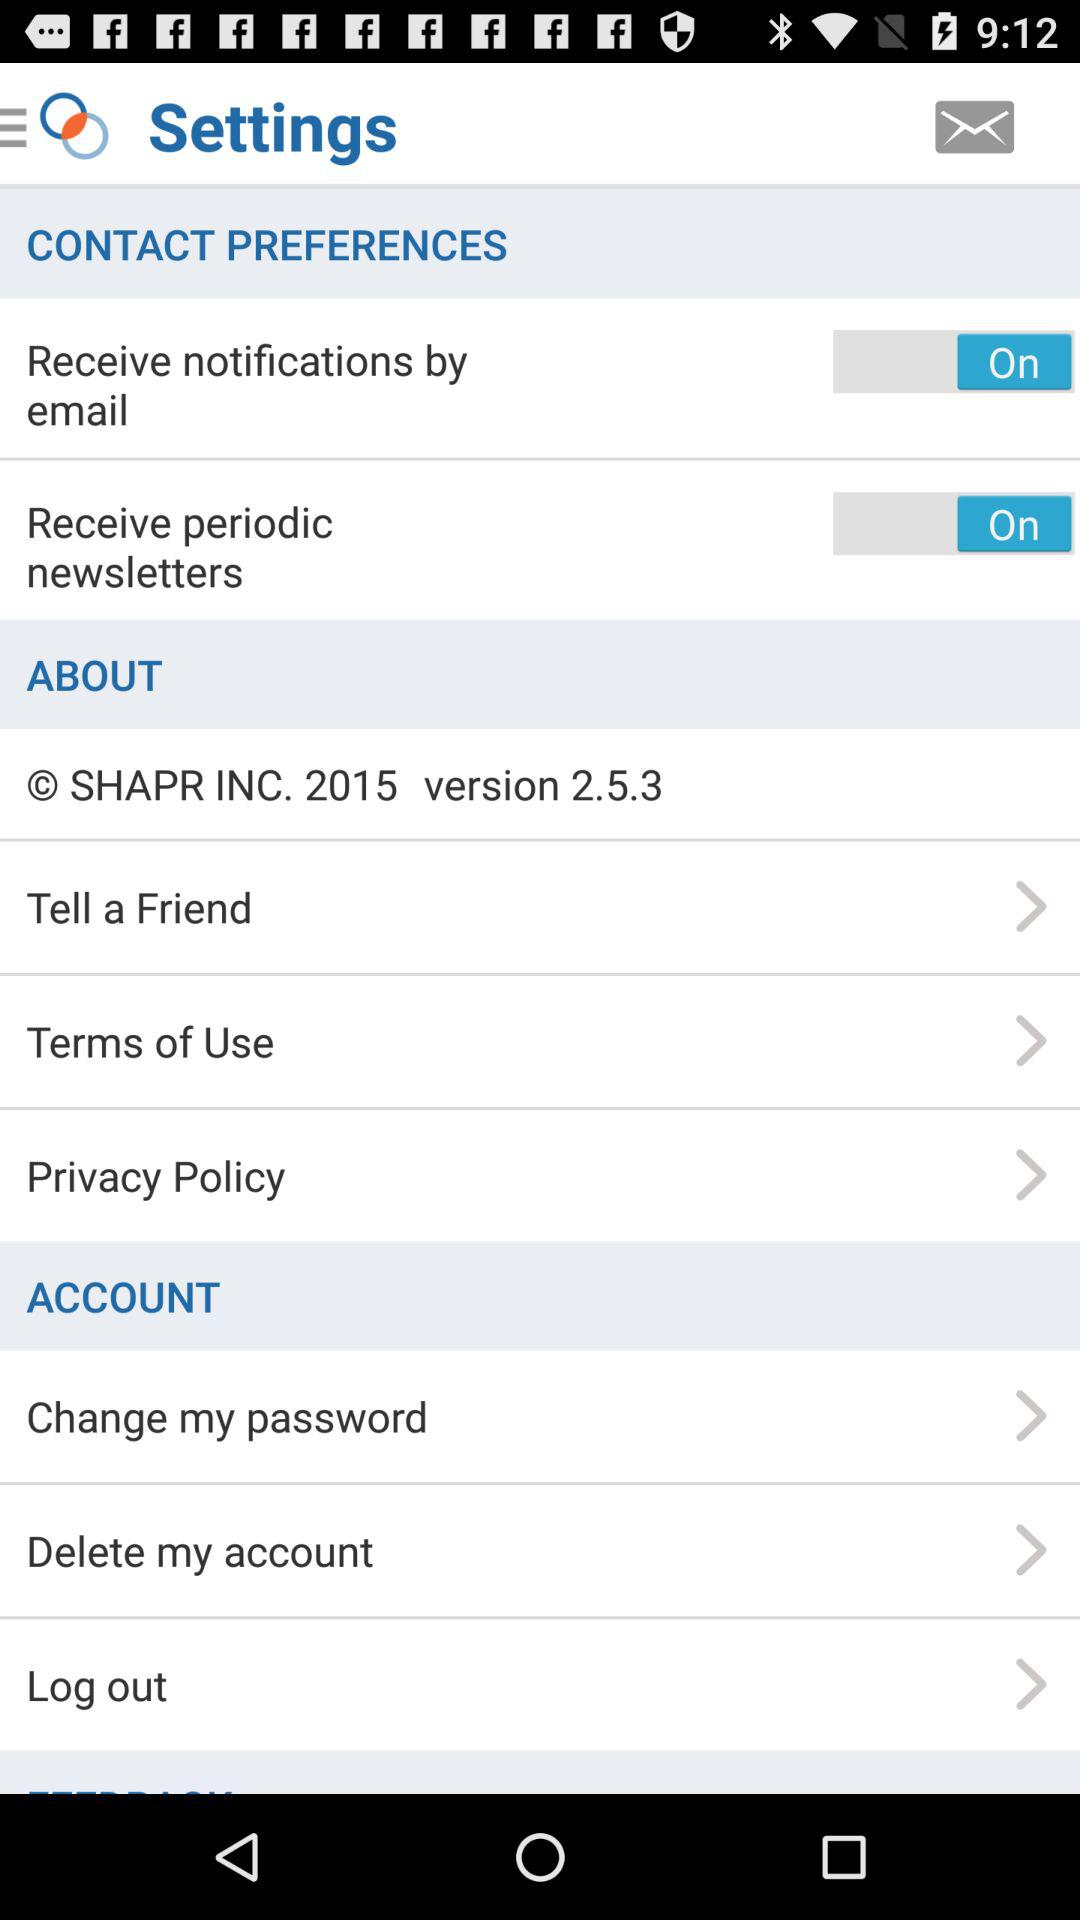What is the status of "Receive notifications by email"? The status is "on". 